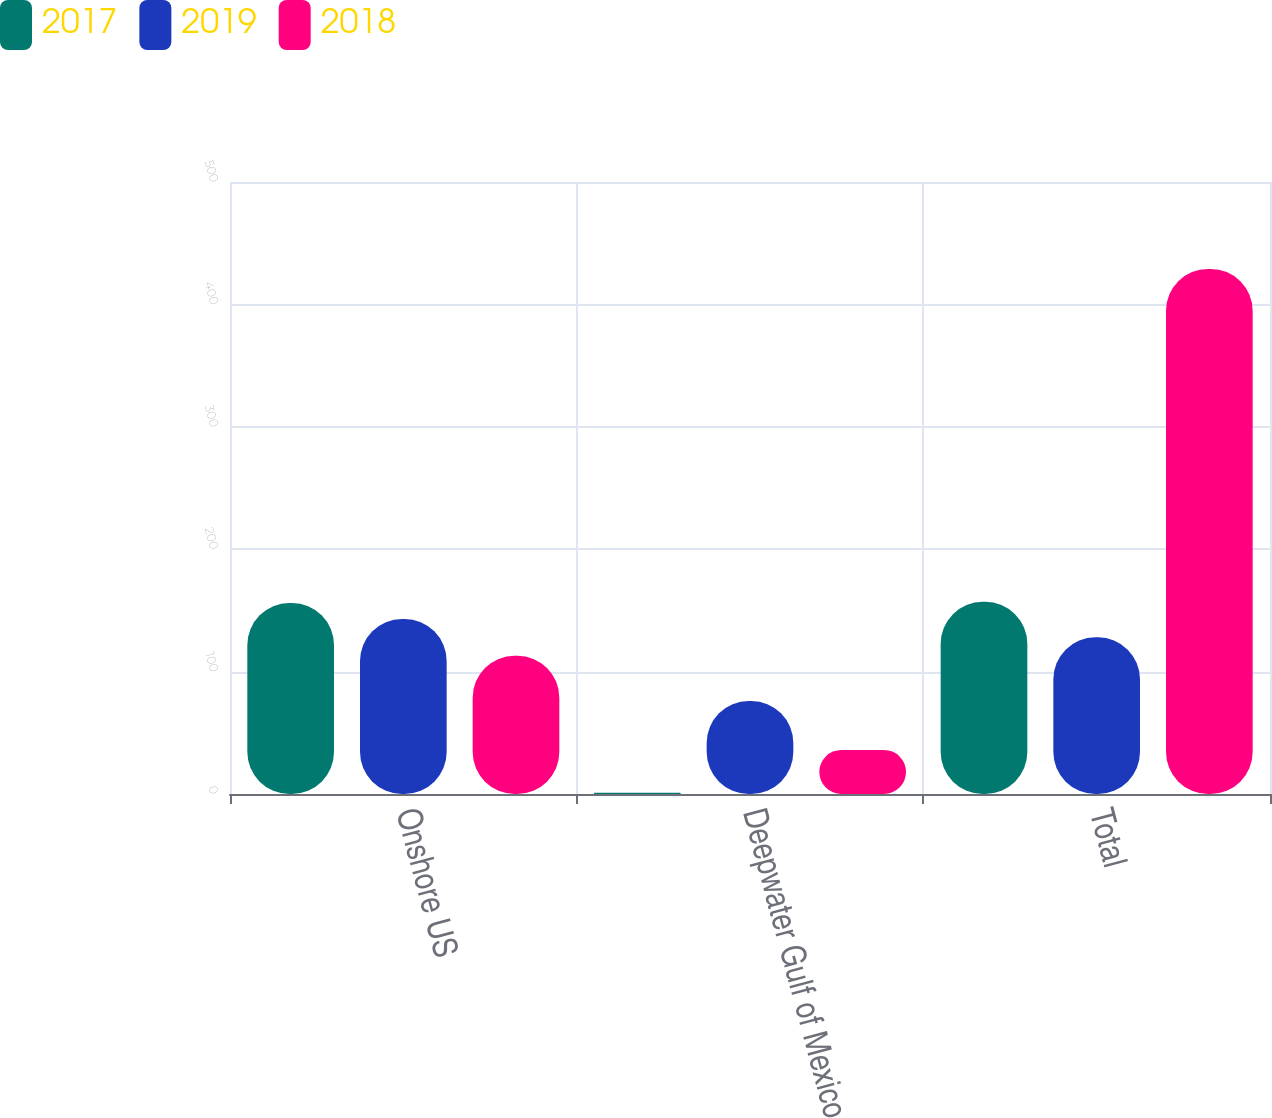<chart> <loc_0><loc_0><loc_500><loc_500><stacked_bar_chart><ecel><fcel>Onshore US<fcel>Deepwater Gulf of Mexico<fcel>Total<nl><fcel>2017<fcel>156<fcel>1<fcel>157<nl><fcel>2019<fcel>143<fcel>76<fcel>128<nl><fcel>2018<fcel>113<fcel>36<fcel>429<nl></chart> 